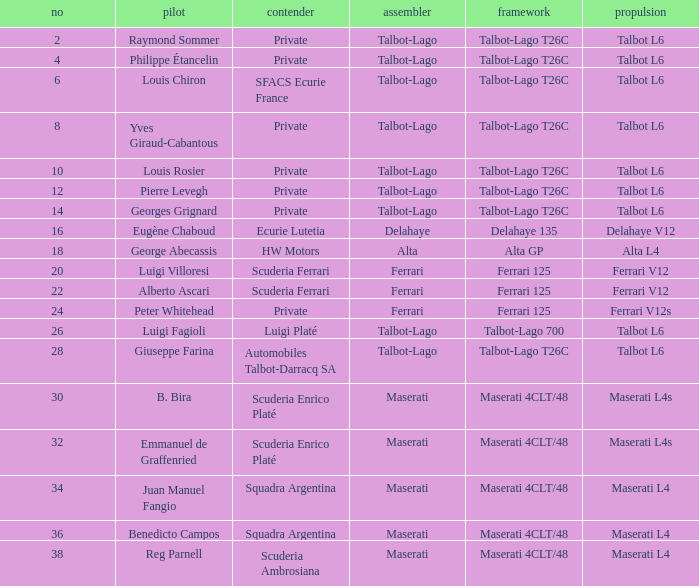Name the constructor for b. bira Maserati. Parse the full table. {'header': ['no', 'pilot', 'contender', 'assembler', 'framework', 'propulsion'], 'rows': [['2', 'Raymond Sommer', 'Private', 'Talbot-Lago', 'Talbot-Lago T26C', 'Talbot L6'], ['4', 'Philippe Étancelin', 'Private', 'Talbot-Lago', 'Talbot-Lago T26C', 'Talbot L6'], ['6', 'Louis Chiron', 'SFACS Ecurie France', 'Talbot-Lago', 'Talbot-Lago T26C', 'Talbot L6'], ['8', 'Yves Giraud-Cabantous', 'Private', 'Talbot-Lago', 'Talbot-Lago T26C', 'Talbot L6'], ['10', 'Louis Rosier', 'Private', 'Talbot-Lago', 'Talbot-Lago T26C', 'Talbot L6'], ['12', 'Pierre Levegh', 'Private', 'Talbot-Lago', 'Talbot-Lago T26C', 'Talbot L6'], ['14', 'Georges Grignard', 'Private', 'Talbot-Lago', 'Talbot-Lago T26C', 'Talbot L6'], ['16', 'Eugène Chaboud', 'Ecurie Lutetia', 'Delahaye', 'Delahaye 135', 'Delahaye V12'], ['18', 'George Abecassis', 'HW Motors', 'Alta', 'Alta GP', 'Alta L4'], ['20', 'Luigi Villoresi', 'Scuderia Ferrari', 'Ferrari', 'Ferrari 125', 'Ferrari V12'], ['22', 'Alberto Ascari', 'Scuderia Ferrari', 'Ferrari', 'Ferrari 125', 'Ferrari V12'], ['24', 'Peter Whitehead', 'Private', 'Ferrari', 'Ferrari 125', 'Ferrari V12s'], ['26', 'Luigi Fagioli', 'Luigi Platé', 'Talbot-Lago', 'Talbot-Lago 700', 'Talbot L6'], ['28', 'Giuseppe Farina', 'Automobiles Talbot-Darracq SA', 'Talbot-Lago', 'Talbot-Lago T26C', 'Talbot L6'], ['30', 'B. Bira', 'Scuderia Enrico Platé', 'Maserati', 'Maserati 4CLT/48', 'Maserati L4s'], ['32', 'Emmanuel de Graffenried', 'Scuderia Enrico Platé', 'Maserati', 'Maserati 4CLT/48', 'Maserati L4s'], ['34', 'Juan Manuel Fangio', 'Squadra Argentina', 'Maserati', 'Maserati 4CLT/48', 'Maserati L4'], ['36', 'Benedicto Campos', 'Squadra Argentina', 'Maserati', 'Maserati 4CLT/48', 'Maserati L4'], ['38', 'Reg Parnell', 'Scuderia Ambrosiana', 'Maserati', 'Maserati 4CLT/48', 'Maserati L4']]} 